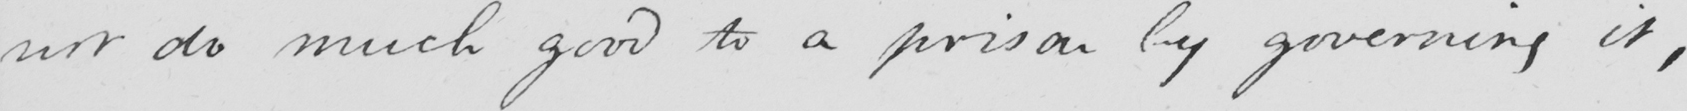What does this handwritten line say? not do much good to a prison by governing it , 